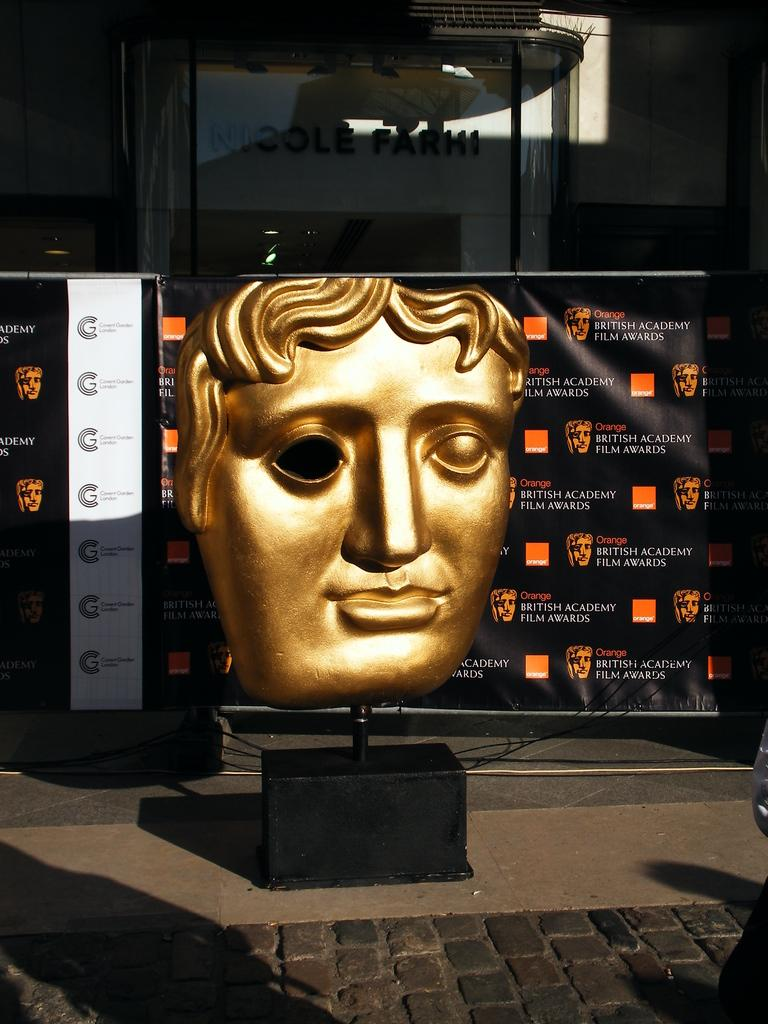What is the main subject of the image? There is a sculpture in the image. What can be seen in the background of the image? There are banners and a wall in the background of the image. What other object is present in the image? There is a board in the image. What type of peace symbol can be seen on the sculpture in the image? There is no peace symbol present on the sculpture in the image. How does the sculpture transport people in the image? The sculpture does not transport people; it is a stationary object. 